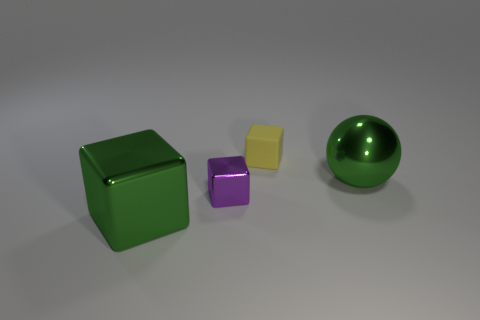Are there any shiny blocks of the same size as the yellow thing?
Offer a terse response. Yes. Is the number of large green things to the left of the yellow object greater than the number of green shiny cubes that are behind the big metal block?
Provide a succinct answer. Yes. Are the tiny thing to the right of the small metallic block and the green object left of the purple metal block made of the same material?
Ensure brevity in your answer.  No. The metallic object that is the same size as the green metal ball is what shape?
Provide a succinct answer. Cube. Is there a large purple metallic thing of the same shape as the matte thing?
Your answer should be compact. No. Do the big metal object that is in front of the metallic ball and the large object that is behind the purple shiny block have the same color?
Provide a short and direct response. Yes. There is a yellow thing; are there any shiny cubes behind it?
Keep it short and to the point. No. There is a object that is both behind the big green metallic block and to the left of the tiny yellow object; what is its material?
Your response must be concise. Metal. Do the small cube that is left of the tiny rubber thing and the big green sphere have the same material?
Ensure brevity in your answer.  Yes. What is the material of the small yellow thing?
Provide a succinct answer. Rubber. 